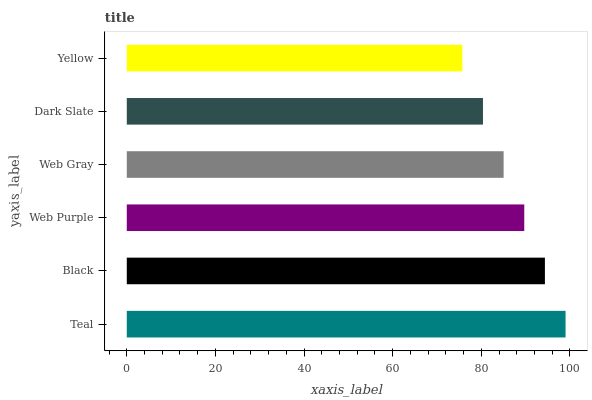Is Yellow the minimum?
Answer yes or no. Yes. Is Teal the maximum?
Answer yes or no. Yes. Is Black the minimum?
Answer yes or no. No. Is Black the maximum?
Answer yes or no. No. Is Teal greater than Black?
Answer yes or no. Yes. Is Black less than Teal?
Answer yes or no. Yes. Is Black greater than Teal?
Answer yes or no. No. Is Teal less than Black?
Answer yes or no. No. Is Web Purple the high median?
Answer yes or no. Yes. Is Web Gray the low median?
Answer yes or no. Yes. Is Black the high median?
Answer yes or no. No. Is Dark Slate the low median?
Answer yes or no. No. 